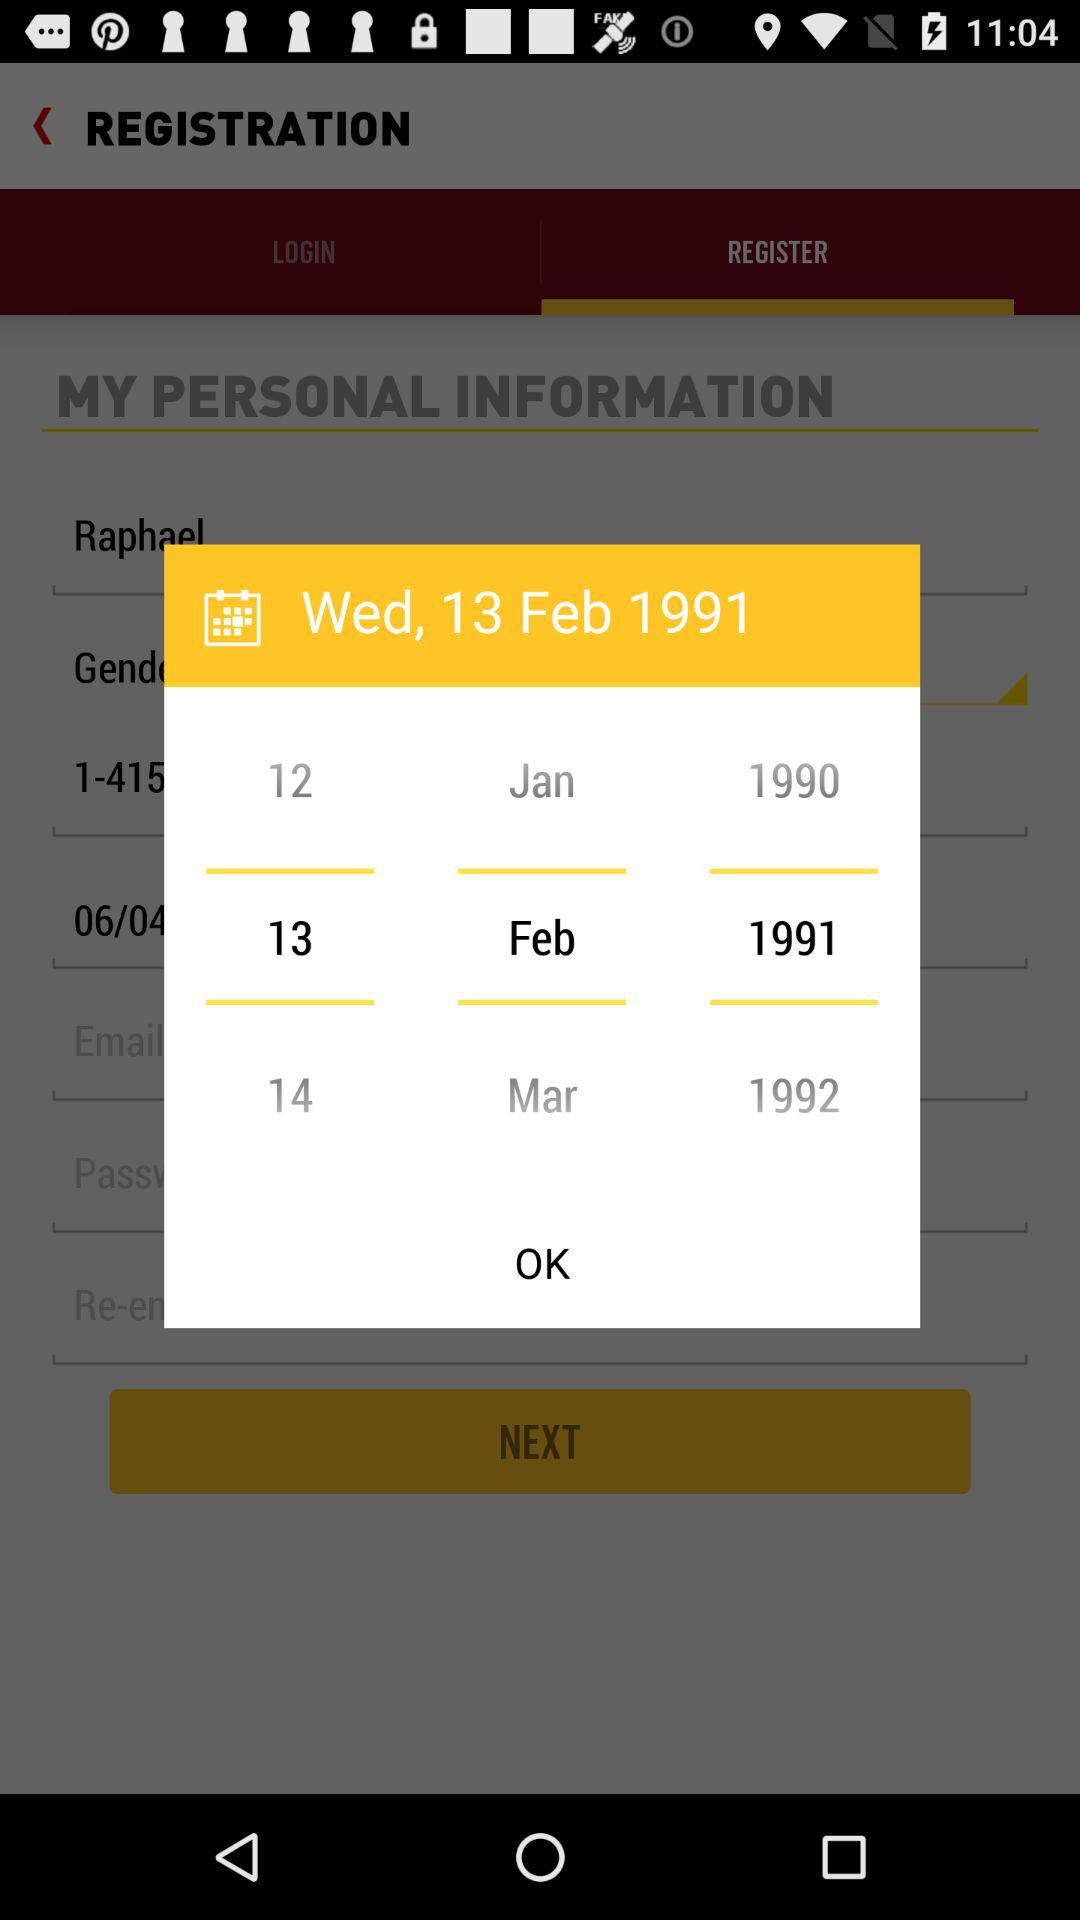Could you tell me more about the layout or style elements of the interface? The interface uses a warm color scheme with a mixture of yellows and browns, and it has a structured layout with the fields for personal information visible above the date selection. It also appears to be designed for easy navigation with large buttons such as 'OK' and 'NEXT'. 